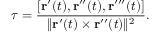<formula> <loc_0><loc_0><loc_500><loc_500>\tau = { \frac { [ r ^ { \prime } ( t ) , r ^ { \prime \prime } ( t ) , r ^ { \prime \prime \prime } ( t ) ] } { \| r ^ { \prime } ( t ) \times r ^ { \prime \prime } ( t ) \| ^ { 2 } } } .</formula> 